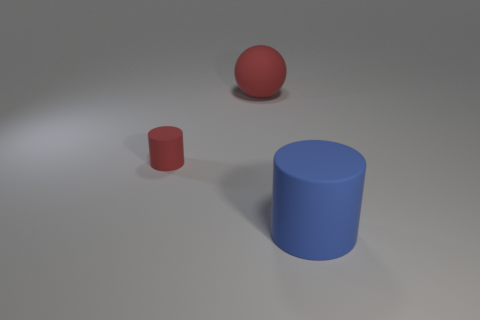Subtract all purple cylinders. Subtract all gray cubes. How many cylinders are left? 2 Subtract all brown cubes. How many yellow spheres are left? 0 Add 3 objects. How many large reds exist? 0 Subtract all blue objects. Subtract all red cylinders. How many objects are left? 1 Add 3 large red rubber objects. How many large red rubber objects are left? 4 Add 1 large brown metal things. How many large brown metal things exist? 1 Add 1 large purple matte balls. How many objects exist? 4 Subtract all blue cylinders. How many cylinders are left? 1 Subtract 0 purple cylinders. How many objects are left? 3 Subtract all cylinders. How many objects are left? 1 